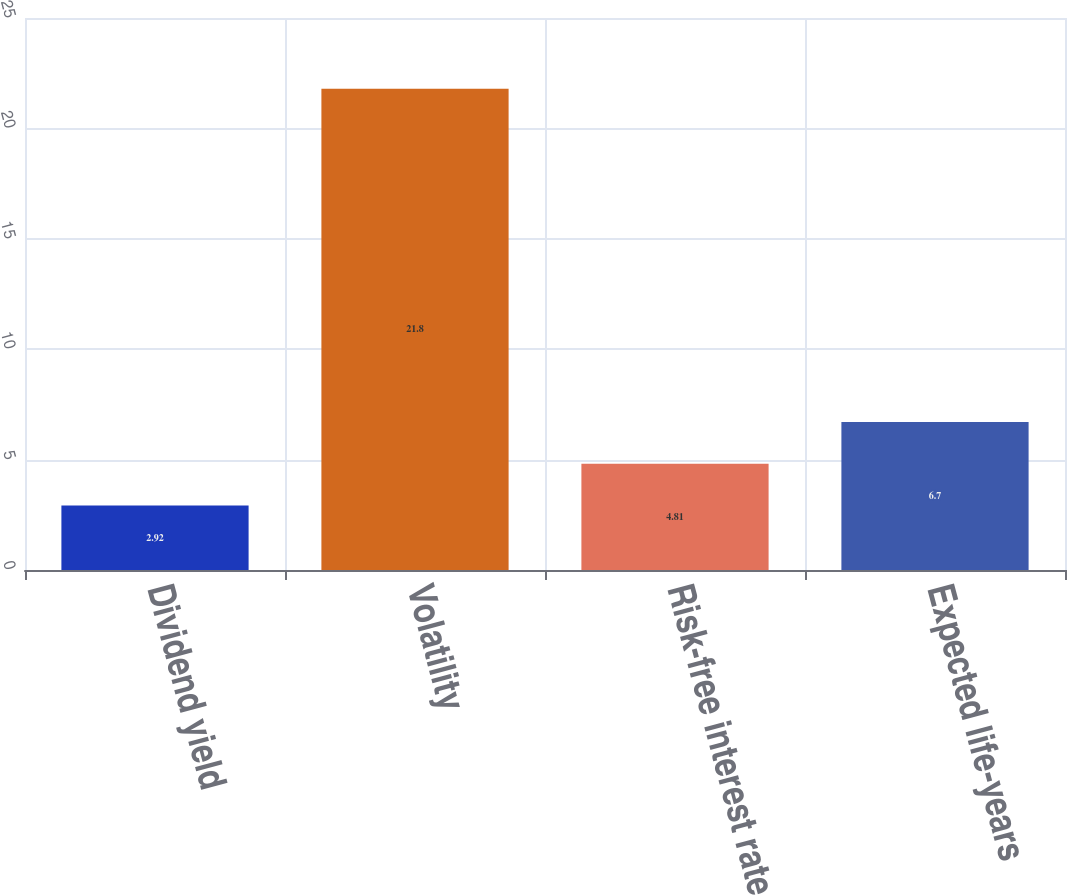Convert chart. <chart><loc_0><loc_0><loc_500><loc_500><bar_chart><fcel>Dividend yield<fcel>Volatility<fcel>Risk-free interest rate<fcel>Expected life-years<nl><fcel>2.92<fcel>21.8<fcel>4.81<fcel>6.7<nl></chart> 